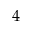<formula> <loc_0><loc_0><loc_500><loc_500>4</formula> 